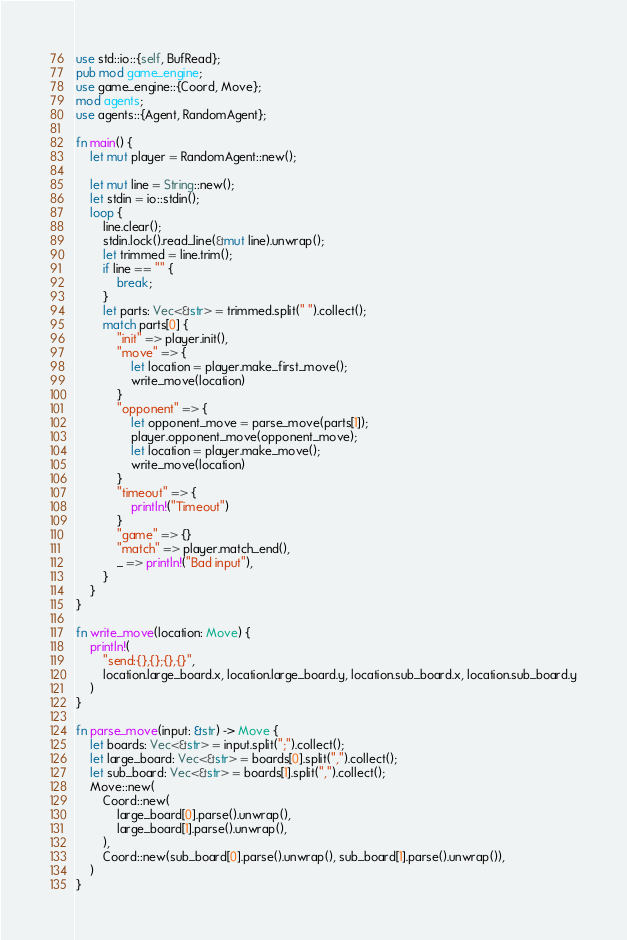<code> <loc_0><loc_0><loc_500><loc_500><_Rust_>use std::io::{self, BufRead};
pub mod game_engine;
use game_engine::{Coord, Move};
mod agents;
use agents::{Agent, RandomAgent};

fn main() {
    let mut player = RandomAgent::new();

    let mut line = String::new();
    let stdin = io::stdin();
    loop {
        line.clear();
        stdin.lock().read_line(&mut line).unwrap();
        let trimmed = line.trim();
        if line == "" {
            break;
        }
        let parts: Vec<&str> = trimmed.split(" ").collect();
        match parts[0] {
            "init" => player.init(),
            "move" => {
                let location = player.make_first_move();
                write_move(location)
            }
            "opponent" => {
                let opponent_move = parse_move(parts[1]);
                player.opponent_move(opponent_move);
                let location = player.make_move();
                write_move(location)
            }
            "timeout" => {
                println!("Timeout")
            }
            "game" => {}
            "match" => player.match_end(),
            _ => println!("Bad input"),
        }
    }
}

fn write_move(location: Move) {
    println!(
        "send:{},{};{},{}",
        location.large_board.x, location.large_board.y, location.sub_board.x, location.sub_board.y
    )
}

fn parse_move(input: &str) -> Move {
    let boards: Vec<&str> = input.split(";").collect();
    let large_board: Vec<&str> = boards[0].split(",").collect();
    let sub_board: Vec<&str> = boards[1].split(",").collect();
    Move::new(
        Coord::new(
            large_board[0].parse().unwrap(),
            large_board[1].parse().unwrap(),
        ),
        Coord::new(sub_board[0].parse().unwrap(), sub_board[1].parse().unwrap()),
    )
}
</code> 